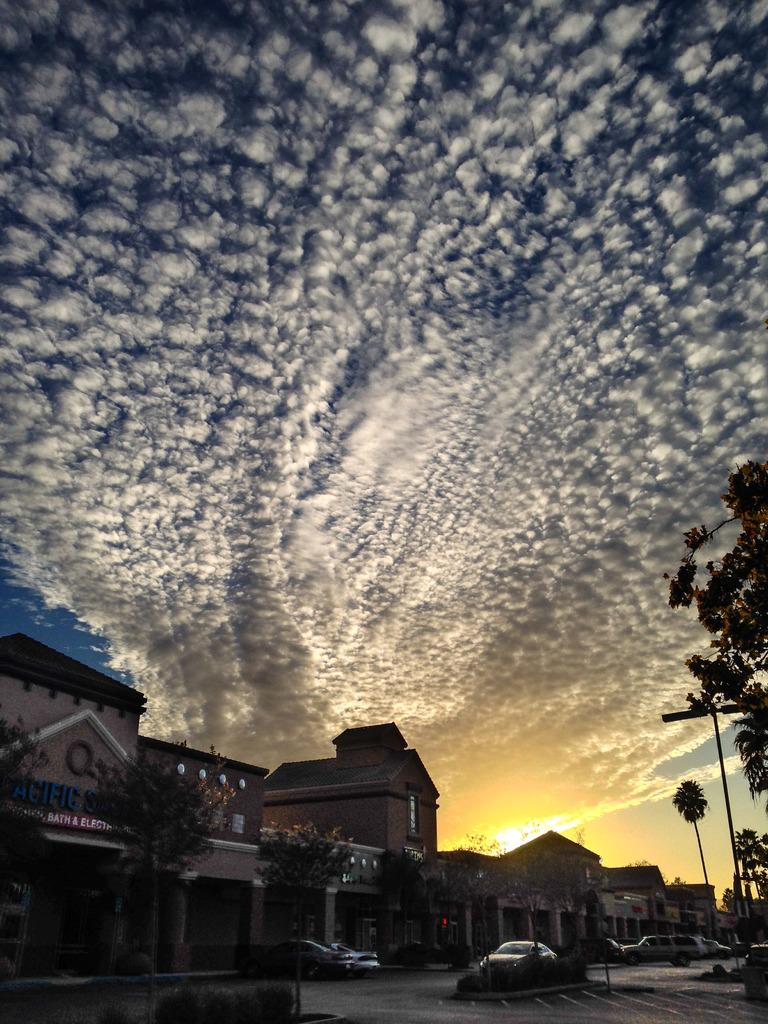What can be seen in the sky in the image? There are clouds in the sky in the image. What type of structures are visible in the image? There are many buildings visible in the image. What type of vegetation is present in the image? There are trees in the image. What type of transportation is visible on the road in the image? There are vehicles on the road in the image. What is the tendency of the van to disappear in the image? There is no van present in the image, so it cannot have a tendency to disappear. 